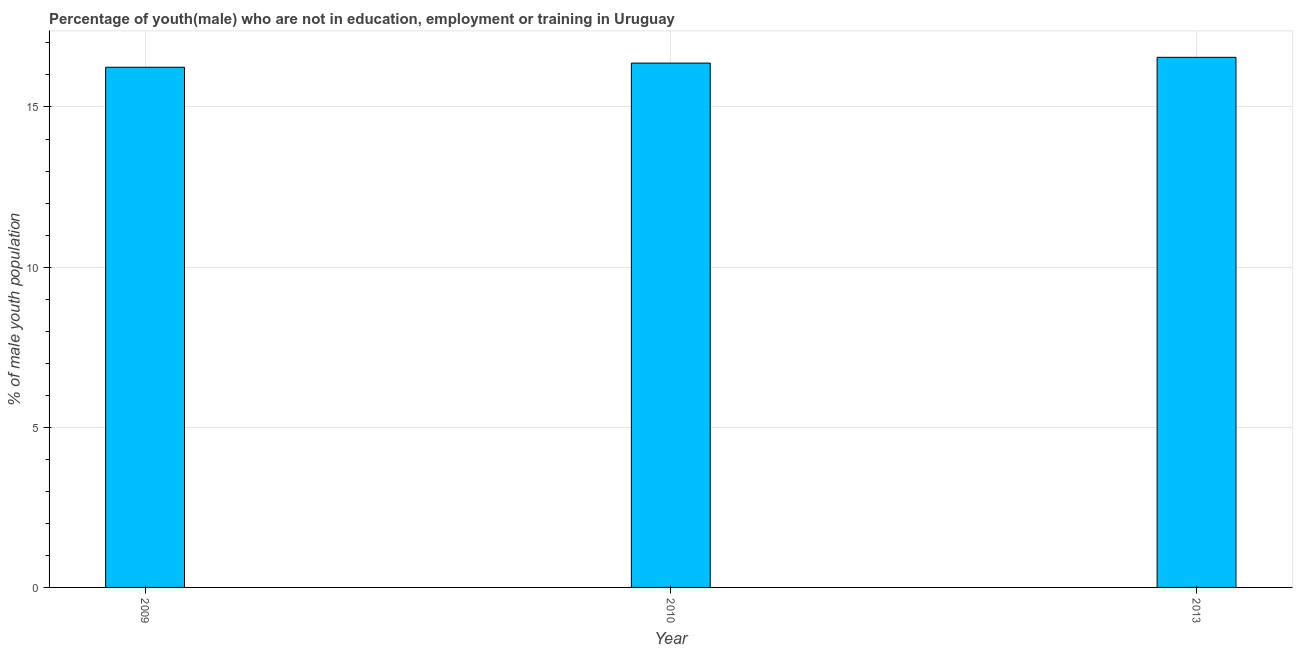What is the title of the graph?
Give a very brief answer. Percentage of youth(male) who are not in education, employment or training in Uruguay. What is the label or title of the Y-axis?
Provide a short and direct response. % of male youth population. What is the unemployed male youth population in 2009?
Ensure brevity in your answer.  16.24. Across all years, what is the maximum unemployed male youth population?
Your response must be concise. 16.55. Across all years, what is the minimum unemployed male youth population?
Ensure brevity in your answer.  16.24. In which year was the unemployed male youth population minimum?
Your answer should be compact. 2009. What is the sum of the unemployed male youth population?
Give a very brief answer. 49.16. What is the difference between the unemployed male youth population in 2009 and 2010?
Offer a terse response. -0.13. What is the average unemployed male youth population per year?
Keep it short and to the point. 16.39. What is the median unemployed male youth population?
Ensure brevity in your answer.  16.37. What is the ratio of the unemployed male youth population in 2010 to that in 2013?
Offer a very short reply. 0.99. What is the difference between the highest and the second highest unemployed male youth population?
Your response must be concise. 0.18. Is the sum of the unemployed male youth population in 2009 and 2013 greater than the maximum unemployed male youth population across all years?
Your answer should be very brief. Yes. What is the difference between the highest and the lowest unemployed male youth population?
Provide a succinct answer. 0.31. In how many years, is the unemployed male youth population greater than the average unemployed male youth population taken over all years?
Provide a succinct answer. 1. How many bars are there?
Keep it short and to the point. 3. What is the difference between two consecutive major ticks on the Y-axis?
Offer a terse response. 5. What is the % of male youth population of 2009?
Make the answer very short. 16.24. What is the % of male youth population of 2010?
Your answer should be very brief. 16.37. What is the % of male youth population in 2013?
Provide a succinct answer. 16.55. What is the difference between the % of male youth population in 2009 and 2010?
Ensure brevity in your answer.  -0.13. What is the difference between the % of male youth population in 2009 and 2013?
Offer a very short reply. -0.31. What is the difference between the % of male youth population in 2010 and 2013?
Keep it short and to the point. -0.18. What is the ratio of the % of male youth population in 2010 to that in 2013?
Your answer should be very brief. 0.99. 